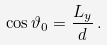<formula> <loc_0><loc_0><loc_500><loc_500>\cos \vartheta _ { 0 } = \frac { L _ { y } } { d } \, .</formula> 